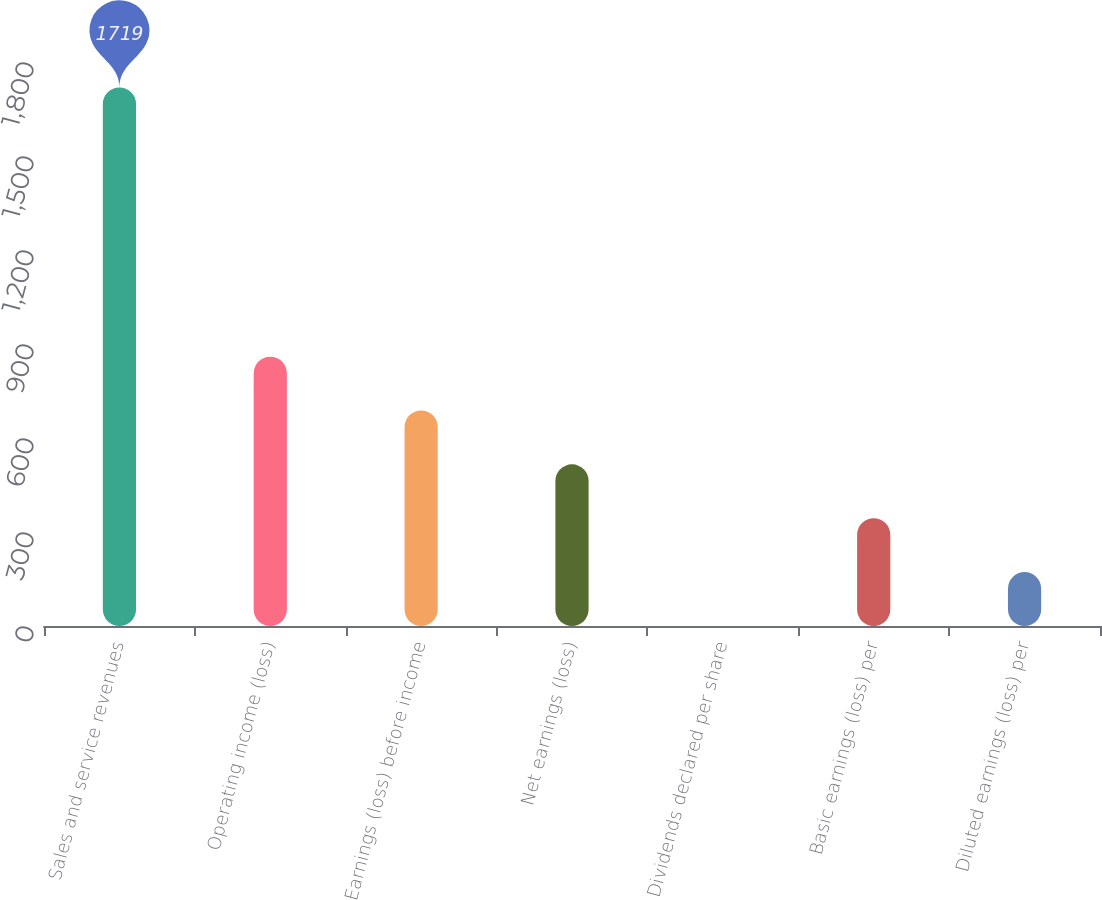<chart> <loc_0><loc_0><loc_500><loc_500><bar_chart><fcel>Sales and service revenues<fcel>Operating income (loss)<fcel>Earnings (loss) before income<fcel>Net earnings (loss)<fcel>Dividends declared per share<fcel>Basic earnings (loss) per<fcel>Diluted earnings (loss) per<nl><fcel>1719<fcel>859.6<fcel>687.72<fcel>515.84<fcel>0.2<fcel>343.96<fcel>172.08<nl></chart> 